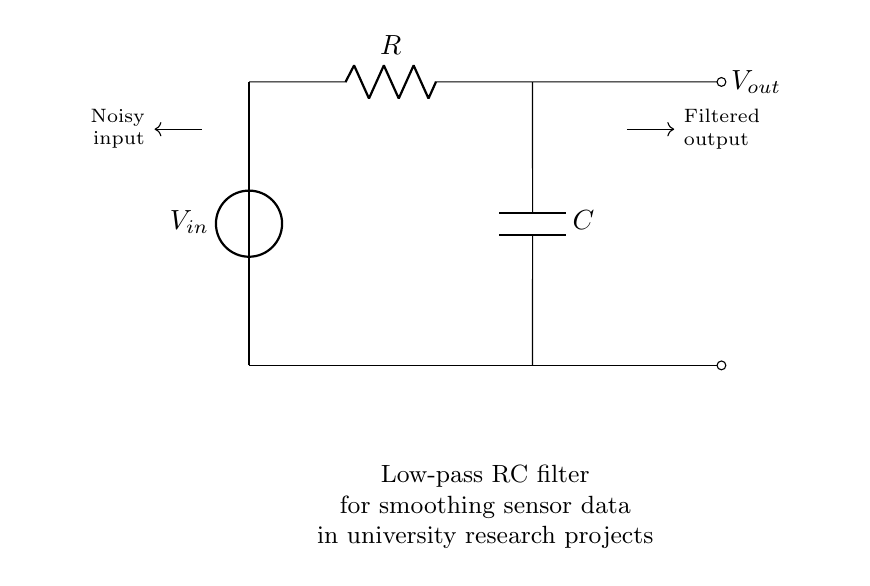What type of filter is represented in this circuit? This circuit diagram represents a low-pass filter because it allows low-frequency signals to pass through while attenuating higher-frequency signals. It consists of a resistor and a capacitor arranged in a specific configuration.
Answer: Low-pass filter What components are in this circuit? The circuit contains a voltage source, a resistor, and a capacitor. These components work together to filter the noisy input signal.
Answer: Resistor, Capacitor What is the purpose of the capacitor in this circuit? The capacitor stores and releases electrical energy, smoothing out fluctuations in the output signal by allowing low-frequency signals to pass while blocking high-frequency noise.
Answer: Smoothing What happens to the output voltage when the input frequency increases? When the input frequency increases, the output voltage decreases due to the filtering effect of the RC circuit, which attenuates higher-frequency signals.
Answer: Decreases How does the resistor value affect the cutoff frequency? The cutoff frequency of an RC circuit is inversely proportional to the resistance value; as the resistance increases, the cutoff frequency decreases, allowing fewer high-frequency signals to pass.
Answer: Decreases What is the relationship between the resistor and capacitor values for the cutoff frequency? The cutoff frequency can be calculated using the formula \( f_c = \frac{1}{2\pi RC} \), showing that both the resistor and capacitor values influence the cutoff frequency combined.
Answer: Inversely proportional 